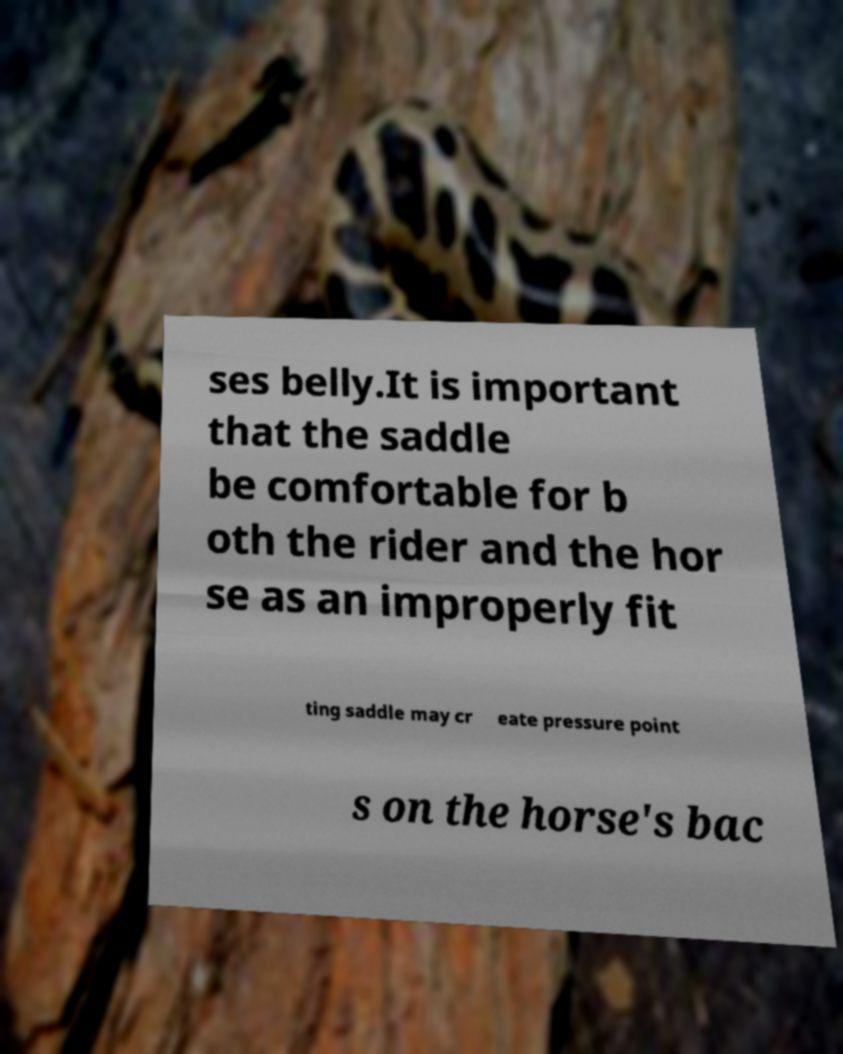For documentation purposes, I need the text within this image transcribed. Could you provide that? ses belly.It is important that the saddle be comfortable for b oth the rider and the hor se as an improperly fit ting saddle may cr eate pressure point s on the horse's bac 